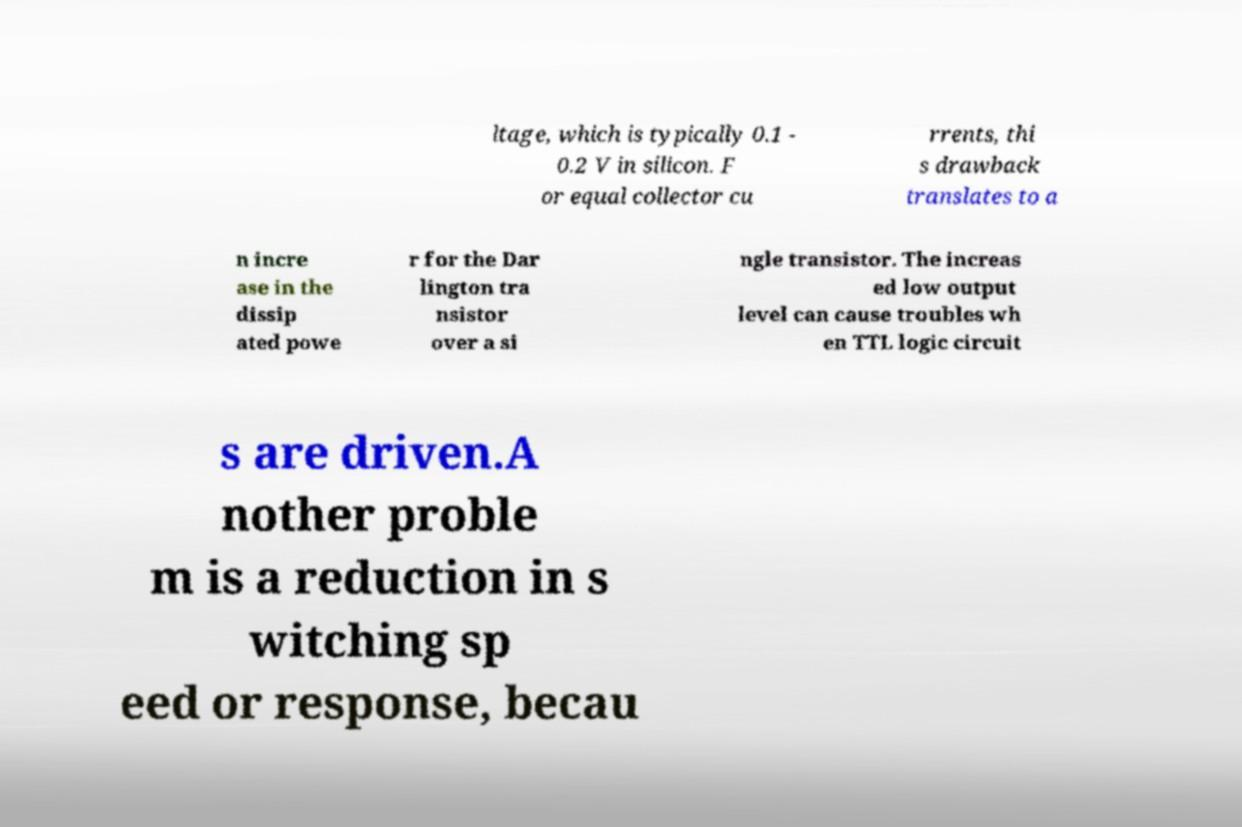Could you extract and type out the text from this image? ltage, which is typically 0.1 - 0.2 V in silicon. F or equal collector cu rrents, thi s drawback translates to a n incre ase in the dissip ated powe r for the Dar lington tra nsistor over a si ngle transistor. The increas ed low output level can cause troubles wh en TTL logic circuit s are driven.A nother proble m is a reduction in s witching sp eed or response, becau 